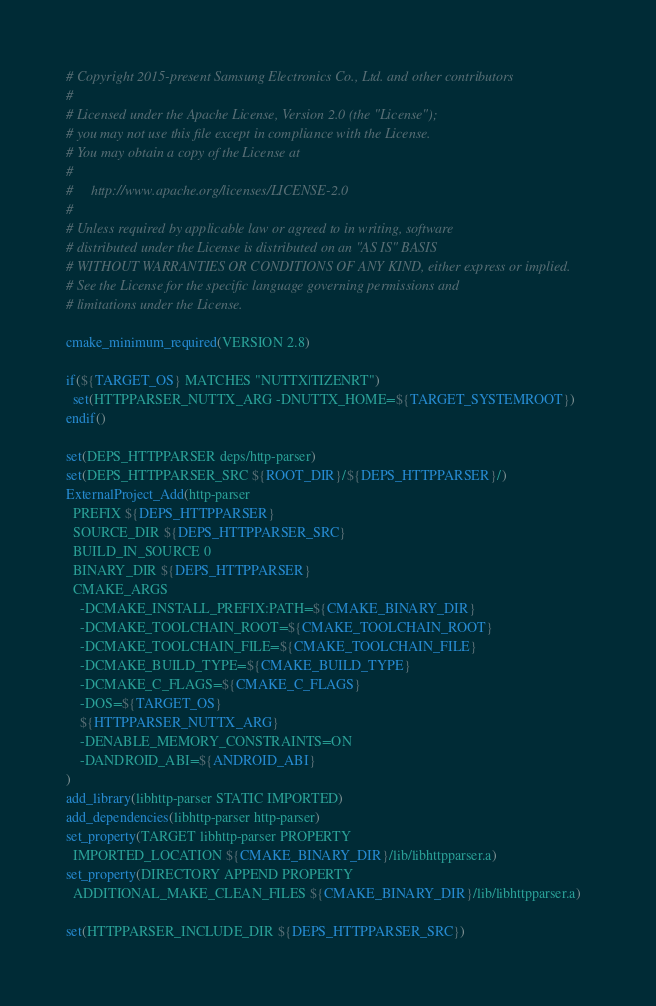<code> <loc_0><loc_0><loc_500><loc_500><_CMake_># Copyright 2015-present Samsung Electronics Co., Ltd. and other contributors
#
# Licensed under the Apache License, Version 2.0 (the "License");
# you may not use this file except in compliance with the License.
# You may obtain a copy of the License at
#
#     http://www.apache.org/licenses/LICENSE-2.0
#
# Unless required by applicable law or agreed to in writing, software
# distributed under the License is distributed on an "AS IS" BASIS
# WITHOUT WARRANTIES OR CONDITIONS OF ANY KIND, either express or implied.
# See the License for the specific language governing permissions and
# limitations under the License.

cmake_minimum_required(VERSION 2.8)

if(${TARGET_OS} MATCHES "NUTTX|TIZENRT")
  set(HTTPPARSER_NUTTX_ARG -DNUTTX_HOME=${TARGET_SYSTEMROOT})
endif()

set(DEPS_HTTPPARSER deps/http-parser)
set(DEPS_HTTPPARSER_SRC ${ROOT_DIR}/${DEPS_HTTPPARSER}/)
ExternalProject_Add(http-parser
  PREFIX ${DEPS_HTTPPARSER}
  SOURCE_DIR ${DEPS_HTTPPARSER_SRC}
  BUILD_IN_SOURCE 0
  BINARY_DIR ${DEPS_HTTPPARSER}
  CMAKE_ARGS
    -DCMAKE_INSTALL_PREFIX:PATH=${CMAKE_BINARY_DIR}
    -DCMAKE_TOOLCHAIN_ROOT=${CMAKE_TOOLCHAIN_ROOT}
    -DCMAKE_TOOLCHAIN_FILE=${CMAKE_TOOLCHAIN_FILE}
    -DCMAKE_BUILD_TYPE=${CMAKE_BUILD_TYPE}
    -DCMAKE_C_FLAGS=${CMAKE_C_FLAGS}
    -DOS=${TARGET_OS}
    ${HTTPPARSER_NUTTX_ARG}
    -DENABLE_MEMORY_CONSTRAINTS=ON
    -DANDROID_ABI=${ANDROID_ABI}
)
add_library(libhttp-parser STATIC IMPORTED)
add_dependencies(libhttp-parser http-parser)
set_property(TARGET libhttp-parser PROPERTY
  IMPORTED_LOCATION ${CMAKE_BINARY_DIR}/lib/libhttpparser.a)
set_property(DIRECTORY APPEND PROPERTY
  ADDITIONAL_MAKE_CLEAN_FILES ${CMAKE_BINARY_DIR}/lib/libhttpparser.a)

set(HTTPPARSER_INCLUDE_DIR ${DEPS_HTTPPARSER_SRC})
</code> 